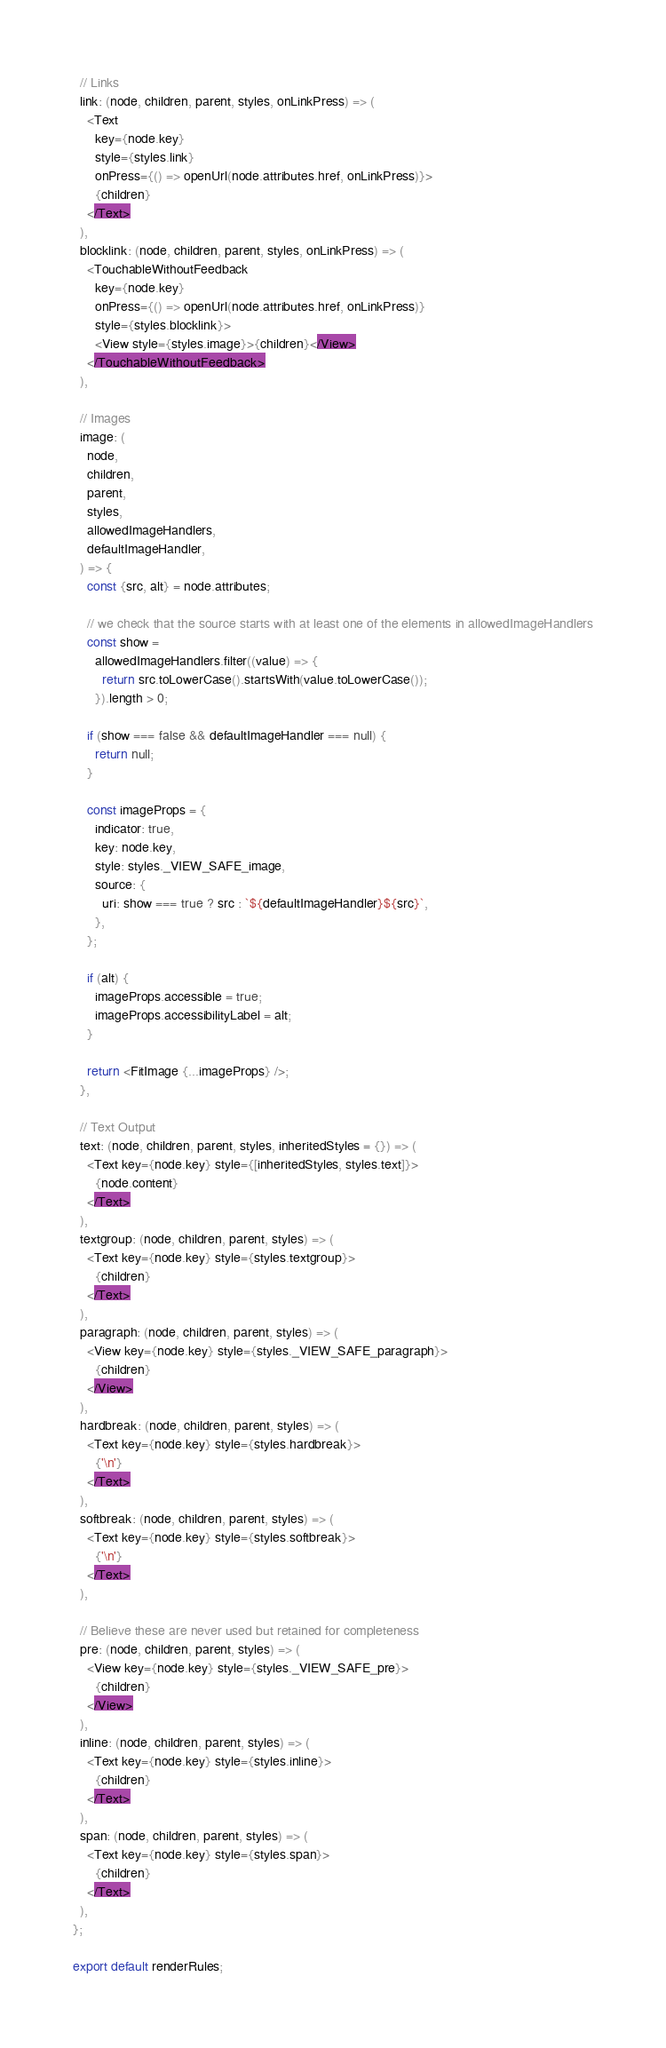Convert code to text. <code><loc_0><loc_0><loc_500><loc_500><_JavaScript_>
  // Links
  link: (node, children, parent, styles, onLinkPress) => (
    <Text
      key={node.key}
      style={styles.link}
      onPress={() => openUrl(node.attributes.href, onLinkPress)}>
      {children}
    </Text>
  ),
  blocklink: (node, children, parent, styles, onLinkPress) => (
    <TouchableWithoutFeedback
      key={node.key}
      onPress={() => openUrl(node.attributes.href, onLinkPress)}
      style={styles.blocklink}>
      <View style={styles.image}>{children}</View>
    </TouchableWithoutFeedback>
  ),

  // Images
  image: (
    node,
    children,
    parent,
    styles,
    allowedImageHandlers,
    defaultImageHandler,
  ) => {
    const {src, alt} = node.attributes;

    // we check that the source starts with at least one of the elements in allowedImageHandlers
    const show =
      allowedImageHandlers.filter((value) => {
        return src.toLowerCase().startsWith(value.toLowerCase());
      }).length > 0;

    if (show === false && defaultImageHandler === null) {
      return null;
    }

    const imageProps = {
      indicator: true,
      key: node.key,
      style: styles._VIEW_SAFE_image,
      source: {
        uri: show === true ? src : `${defaultImageHandler}${src}`,
      },
    };

    if (alt) {
      imageProps.accessible = true;
      imageProps.accessibilityLabel = alt;
    }

    return <FitImage {...imageProps} />;
  },

  // Text Output
  text: (node, children, parent, styles, inheritedStyles = {}) => (
    <Text key={node.key} style={[inheritedStyles, styles.text]}>
      {node.content}
    </Text>
  ),
  textgroup: (node, children, parent, styles) => (
    <Text key={node.key} style={styles.textgroup}>
      {children}
    </Text>
  ),
  paragraph: (node, children, parent, styles) => (
    <View key={node.key} style={styles._VIEW_SAFE_paragraph}>
      {children}
    </View>
  ),
  hardbreak: (node, children, parent, styles) => (
    <Text key={node.key} style={styles.hardbreak}>
      {'\n'}
    </Text>
  ),
  softbreak: (node, children, parent, styles) => (
    <Text key={node.key} style={styles.softbreak}>
      {'\n'}
    </Text>
  ),

  // Believe these are never used but retained for completeness
  pre: (node, children, parent, styles) => (
    <View key={node.key} style={styles._VIEW_SAFE_pre}>
      {children}
    </View>
  ),
  inline: (node, children, parent, styles) => (
    <Text key={node.key} style={styles.inline}>
      {children}
    </Text>
  ),
  span: (node, children, parent, styles) => (
    <Text key={node.key} style={styles.span}>
      {children}
    </Text>
  ),
};

export default renderRules;
</code> 